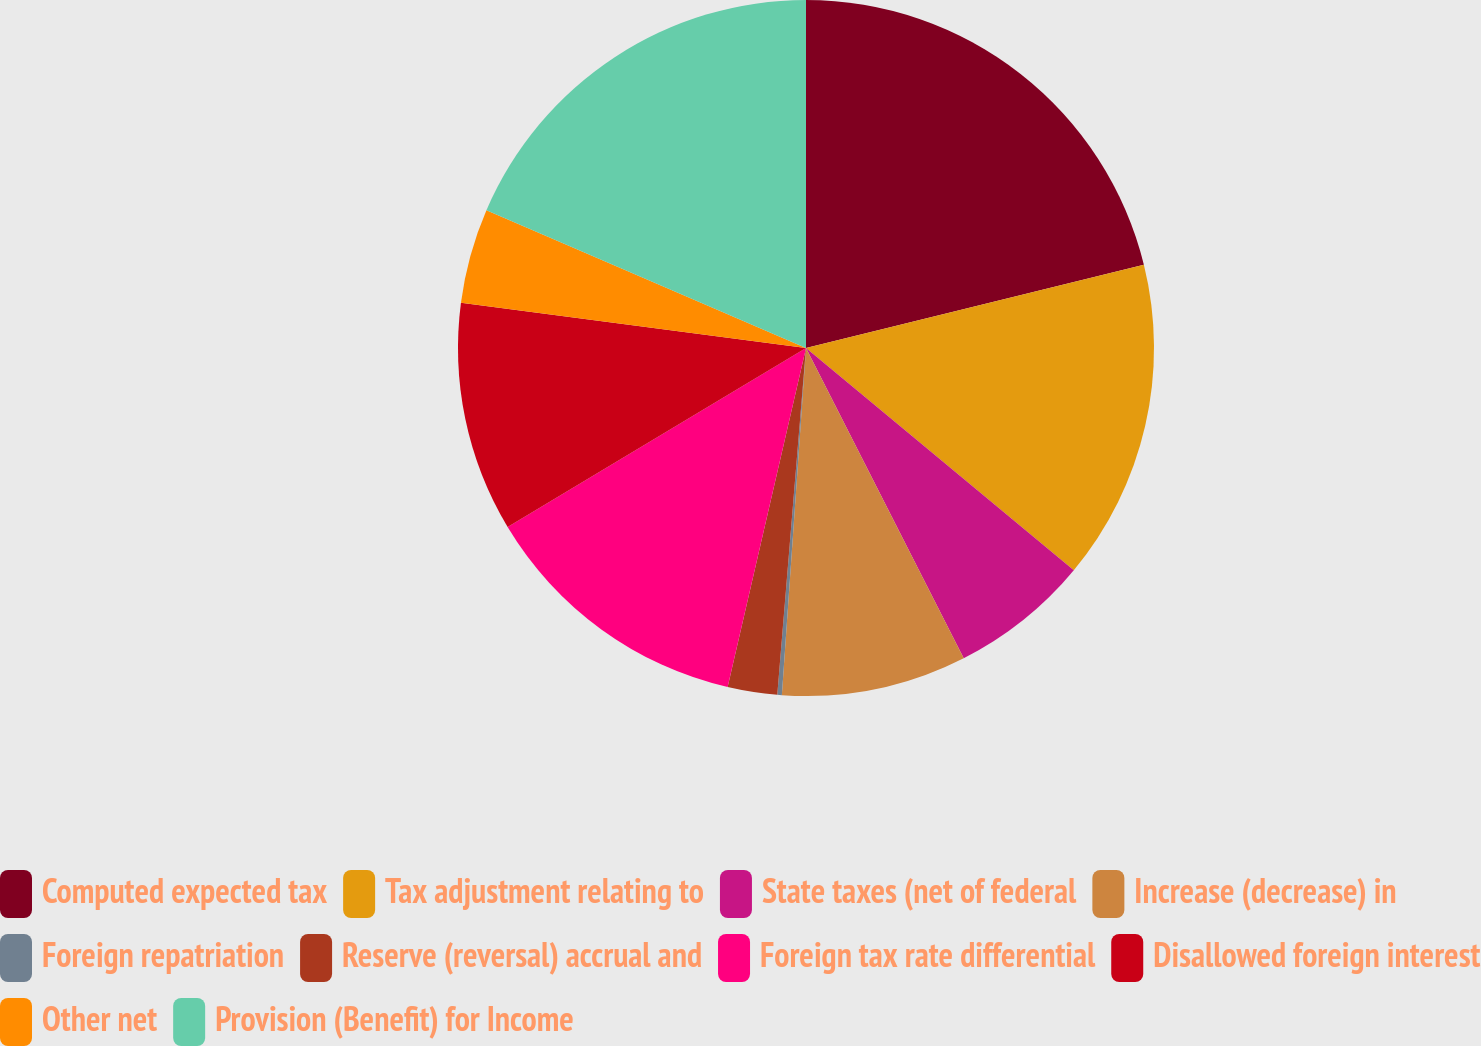<chart> <loc_0><loc_0><loc_500><loc_500><pie_chart><fcel>Computed expected tax<fcel>Tax adjustment relating to<fcel>State taxes (net of federal<fcel>Increase (decrease) in<fcel>Foreign repatriation<fcel>Reserve (reversal) accrual and<fcel>Foreign tax rate differential<fcel>Disallowed foreign interest<fcel>Other net<fcel>Provision (Benefit) for Income<nl><fcel>21.15%<fcel>14.87%<fcel>6.49%<fcel>8.59%<fcel>0.21%<fcel>2.3%<fcel>12.78%<fcel>10.68%<fcel>4.4%<fcel>18.52%<nl></chart> 